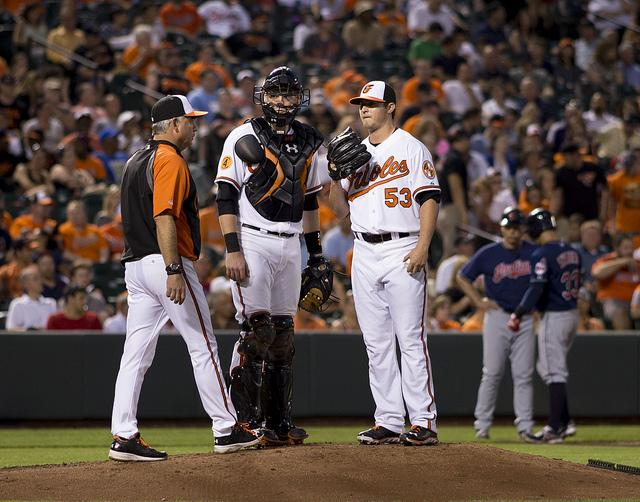Where are the three men in orange and white having their discussion? pitcher's mound 